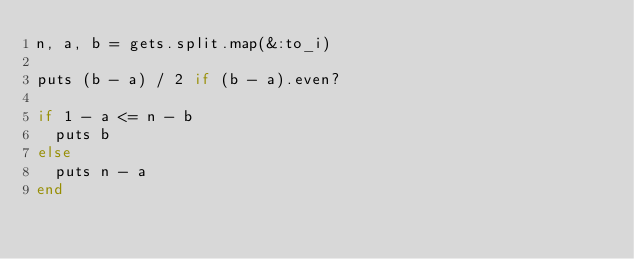<code> <loc_0><loc_0><loc_500><loc_500><_Ruby_>n, a, b = gets.split.map(&:to_i)

puts (b - a) / 2 if (b - a).even?

if 1 - a <= n - b
  puts b
else
  puts n - a
end</code> 